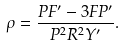<formula> <loc_0><loc_0><loc_500><loc_500>\rho = \frac { P F ^ { \prime } - 3 F P ^ { \prime } } { P ^ { 2 } R ^ { 2 } Y ^ { \prime } } .</formula> 